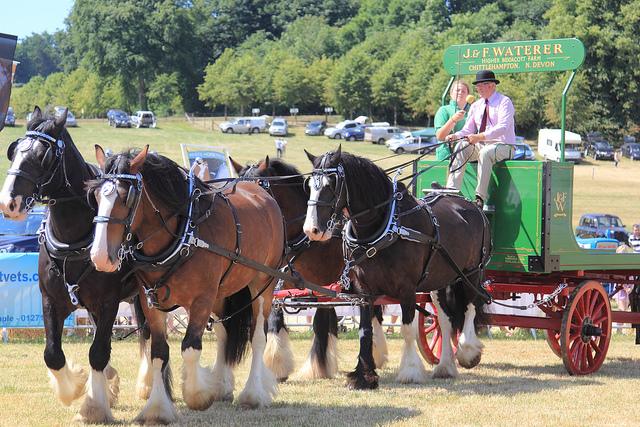How many horses are in the photo?
Concise answer only. 4. Where is the green in the photo?
Answer briefly. Wagon. What breed of horses are these?
Quick response, please. Clydesdales. 